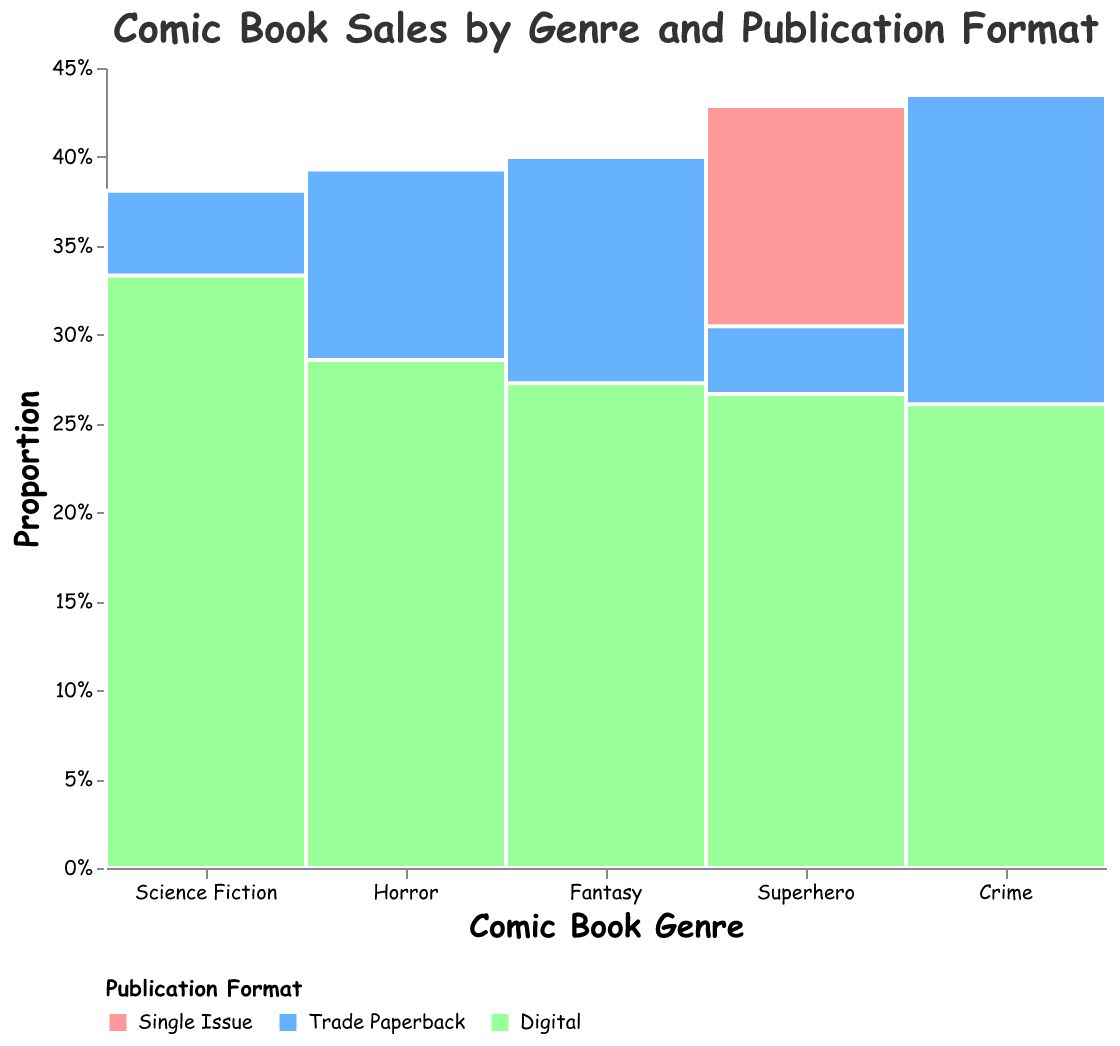What is the title of the figure? The title of a figure is usually displayed at the top and summarizes what the figure is about. In this case, the title clearly states it is about comic book sales by genre and publication format.
Answer: Comic Book Sales by Genre and Publication Format Which genre has the highest sales in the format 'Single Issue'? By looking at the Mosaic Plot, the height of the bars in the 'Single Issue' section represents sales. The Superhero genre has the tallest bar in this section.
Answer: Superhero How do the sales of Trade Paperbacks compare between the Fantasy and Crime genres? In the Mosaic Plot, the height of the Trade Paperback sections for Fantasy and Crime genres can be compared directly. The bar for Fantasy is taller than the bar for Crime, indicating higher sales.
Answer: Fantasy has higher sales than Crime What proportion of the total sales for Superhero comics is in the digital format? The percentage of total sales in the digital format for Superhero comics can be seen by observing the proportion of the bar for the Superhero genre corresponding to the digital format.
Answer: About 27.18% Which format has the lowest sales across all genres? To determine which format has the lowest sales across all genres, compare the heights of the bars corresponding to each format. The Digital format consistently has shorter bars compared to Single Issue and Trade Paperback.
Answer: Digital What is the difference in sales between Single Issue and Digital formats within the Fantasy genre? Look at the height of the bars for Single Issue and Digital formats within the Fantasy genre to see their sales. Subtract the Digital sales from the Single Issue sales: 180,000 - 150,000
Answer: 30,000 In which genre is the share of sales for Trade Paperback the highest? The highest share of sales for Trade Paperback in a genre can be identified by comparing the proportion of the Trade Paperback section in each genre. This will correspond to the tallest segment for Trade Paperback.
Answer: Fantasy How do Science Fiction and Horror compare in terms of total sales? To compare the total sales of Science Fiction and Horror, look at the total heights of the bars for these genres. Science Fiction bars are taller compared to Horror bars, indicating higher total sales in Science Fiction.
Answer: Science Fiction has higher total sales than Horror Which genre has the smallest proportion of its sales in the Single Issue format? Examine the proportion of Single Issue sales for each genre within the Mosaic Plot. The genre with the smallest segment in the Single Issue section will have the lowest proportion.
Answer: Crime 